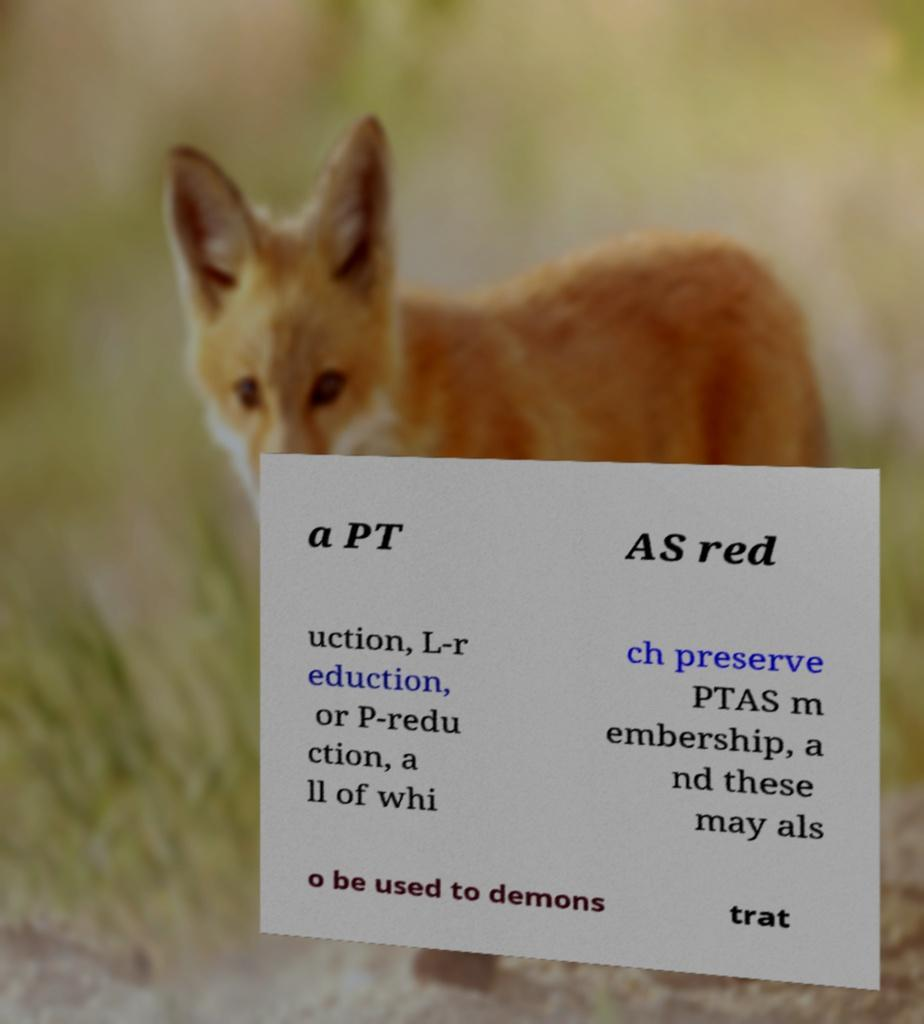Please identify and transcribe the text found in this image. a PT AS red uction, L-r eduction, or P-redu ction, a ll of whi ch preserve PTAS m embership, a nd these may als o be used to demons trat 